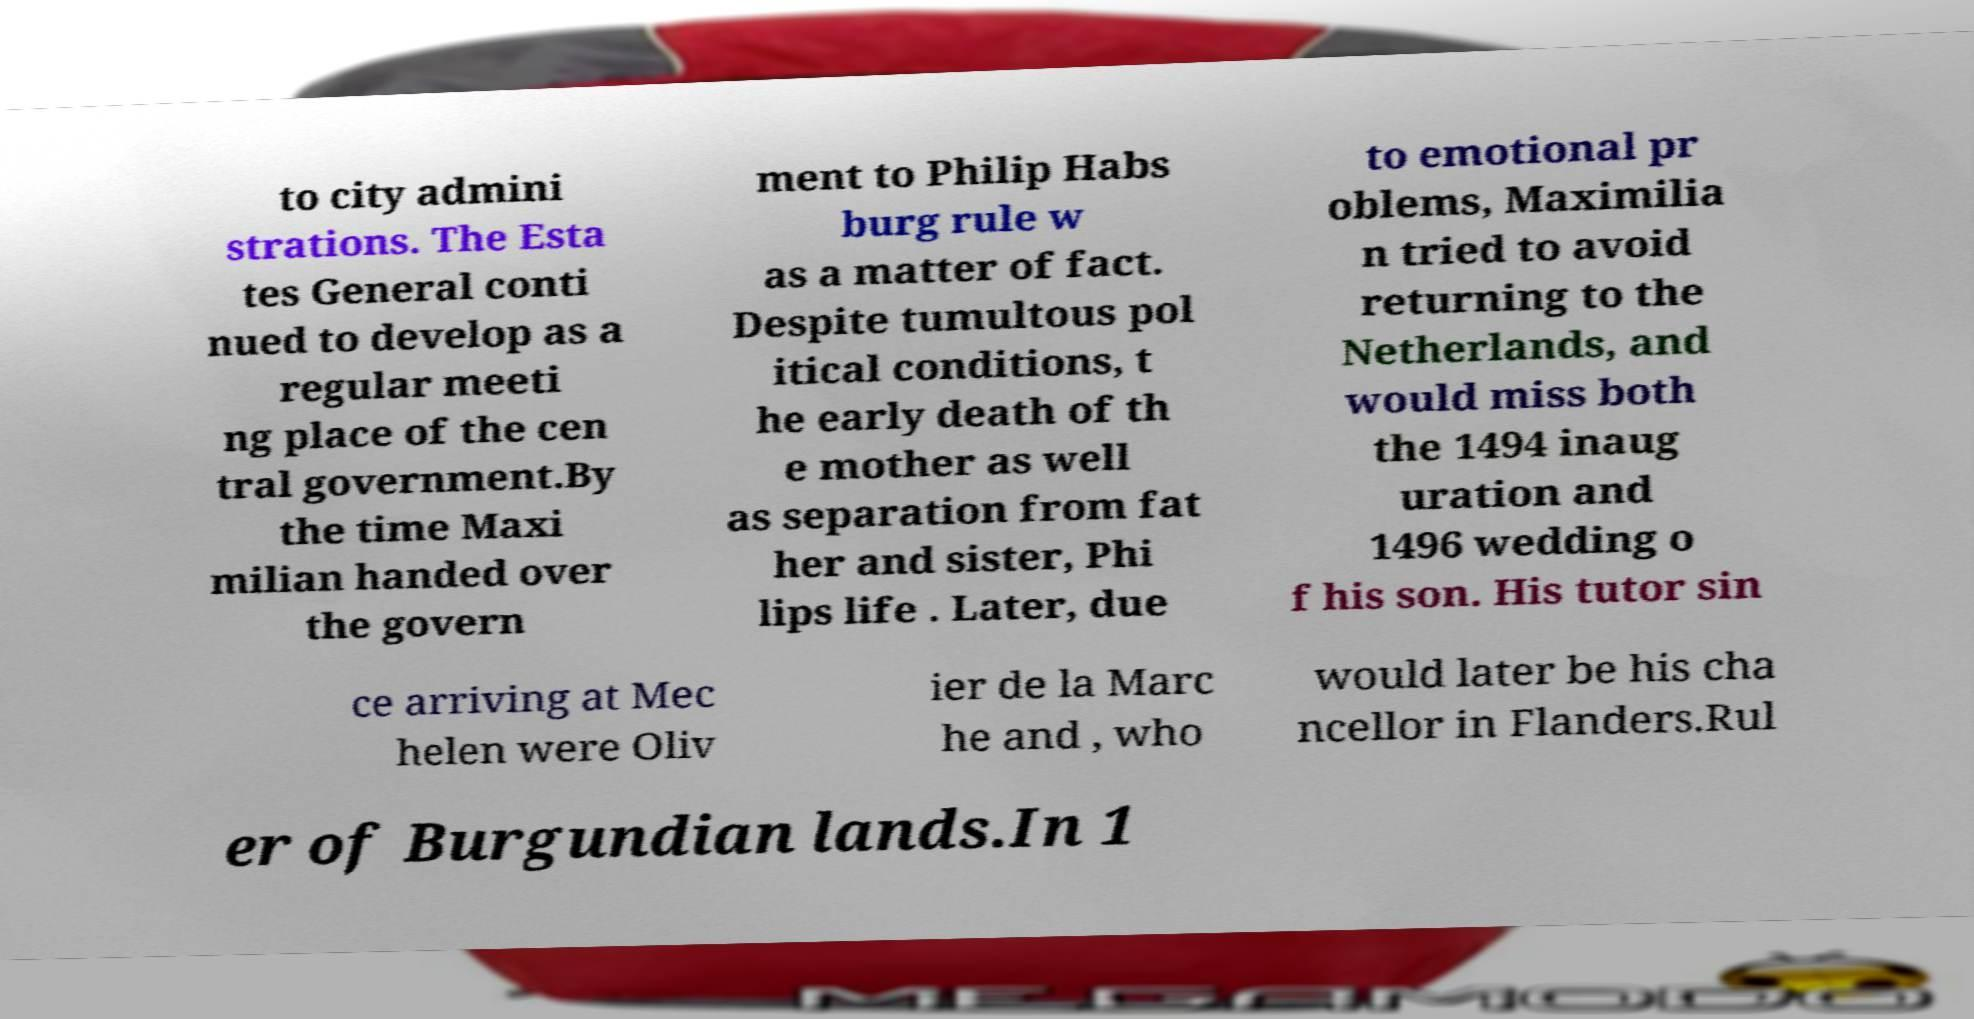Can you accurately transcribe the text from the provided image for me? to city admini strations. The Esta tes General conti nued to develop as a regular meeti ng place of the cen tral government.By the time Maxi milian handed over the govern ment to Philip Habs burg rule w as a matter of fact. Despite tumultous pol itical conditions, t he early death of th e mother as well as separation from fat her and sister, Phi lips life . Later, due to emotional pr oblems, Maximilia n tried to avoid returning to the Netherlands, and would miss both the 1494 inaug uration and 1496 wedding o f his son. His tutor sin ce arriving at Mec helen were Oliv ier de la Marc he and , who would later be his cha ncellor in Flanders.Rul er of Burgundian lands.In 1 